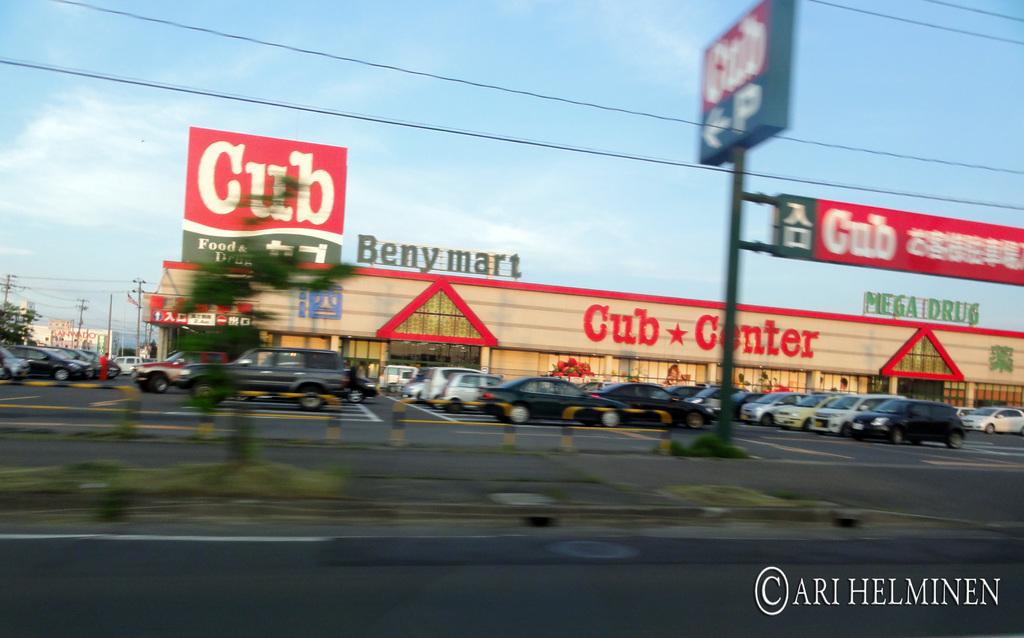Does the cub store serve food?
Your response must be concise. Yes. What is the name of the mart?
Give a very brief answer. Benymart. 